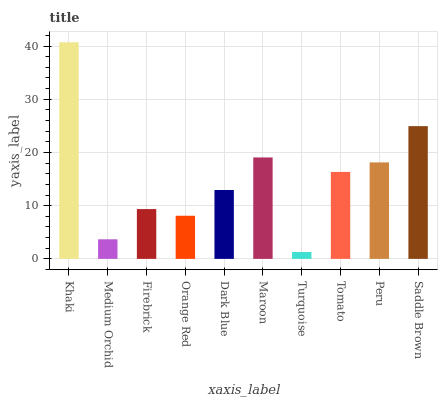Is Turquoise the minimum?
Answer yes or no. Yes. Is Khaki the maximum?
Answer yes or no. Yes. Is Medium Orchid the minimum?
Answer yes or no. No. Is Medium Orchid the maximum?
Answer yes or no. No. Is Khaki greater than Medium Orchid?
Answer yes or no. Yes. Is Medium Orchid less than Khaki?
Answer yes or no. Yes. Is Medium Orchid greater than Khaki?
Answer yes or no. No. Is Khaki less than Medium Orchid?
Answer yes or no. No. Is Tomato the high median?
Answer yes or no. Yes. Is Dark Blue the low median?
Answer yes or no. Yes. Is Turquoise the high median?
Answer yes or no. No. Is Orange Red the low median?
Answer yes or no. No. 